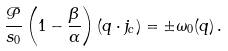Convert formula to latex. <formula><loc_0><loc_0><loc_500><loc_500>\frac { \mathcal { P } } { s _ { 0 } } \left ( 1 - \frac { \beta } { \alpha } \right ) ( q \cdot j _ { c } ) = \pm \omega _ { 0 } ( q ) \, .</formula> 